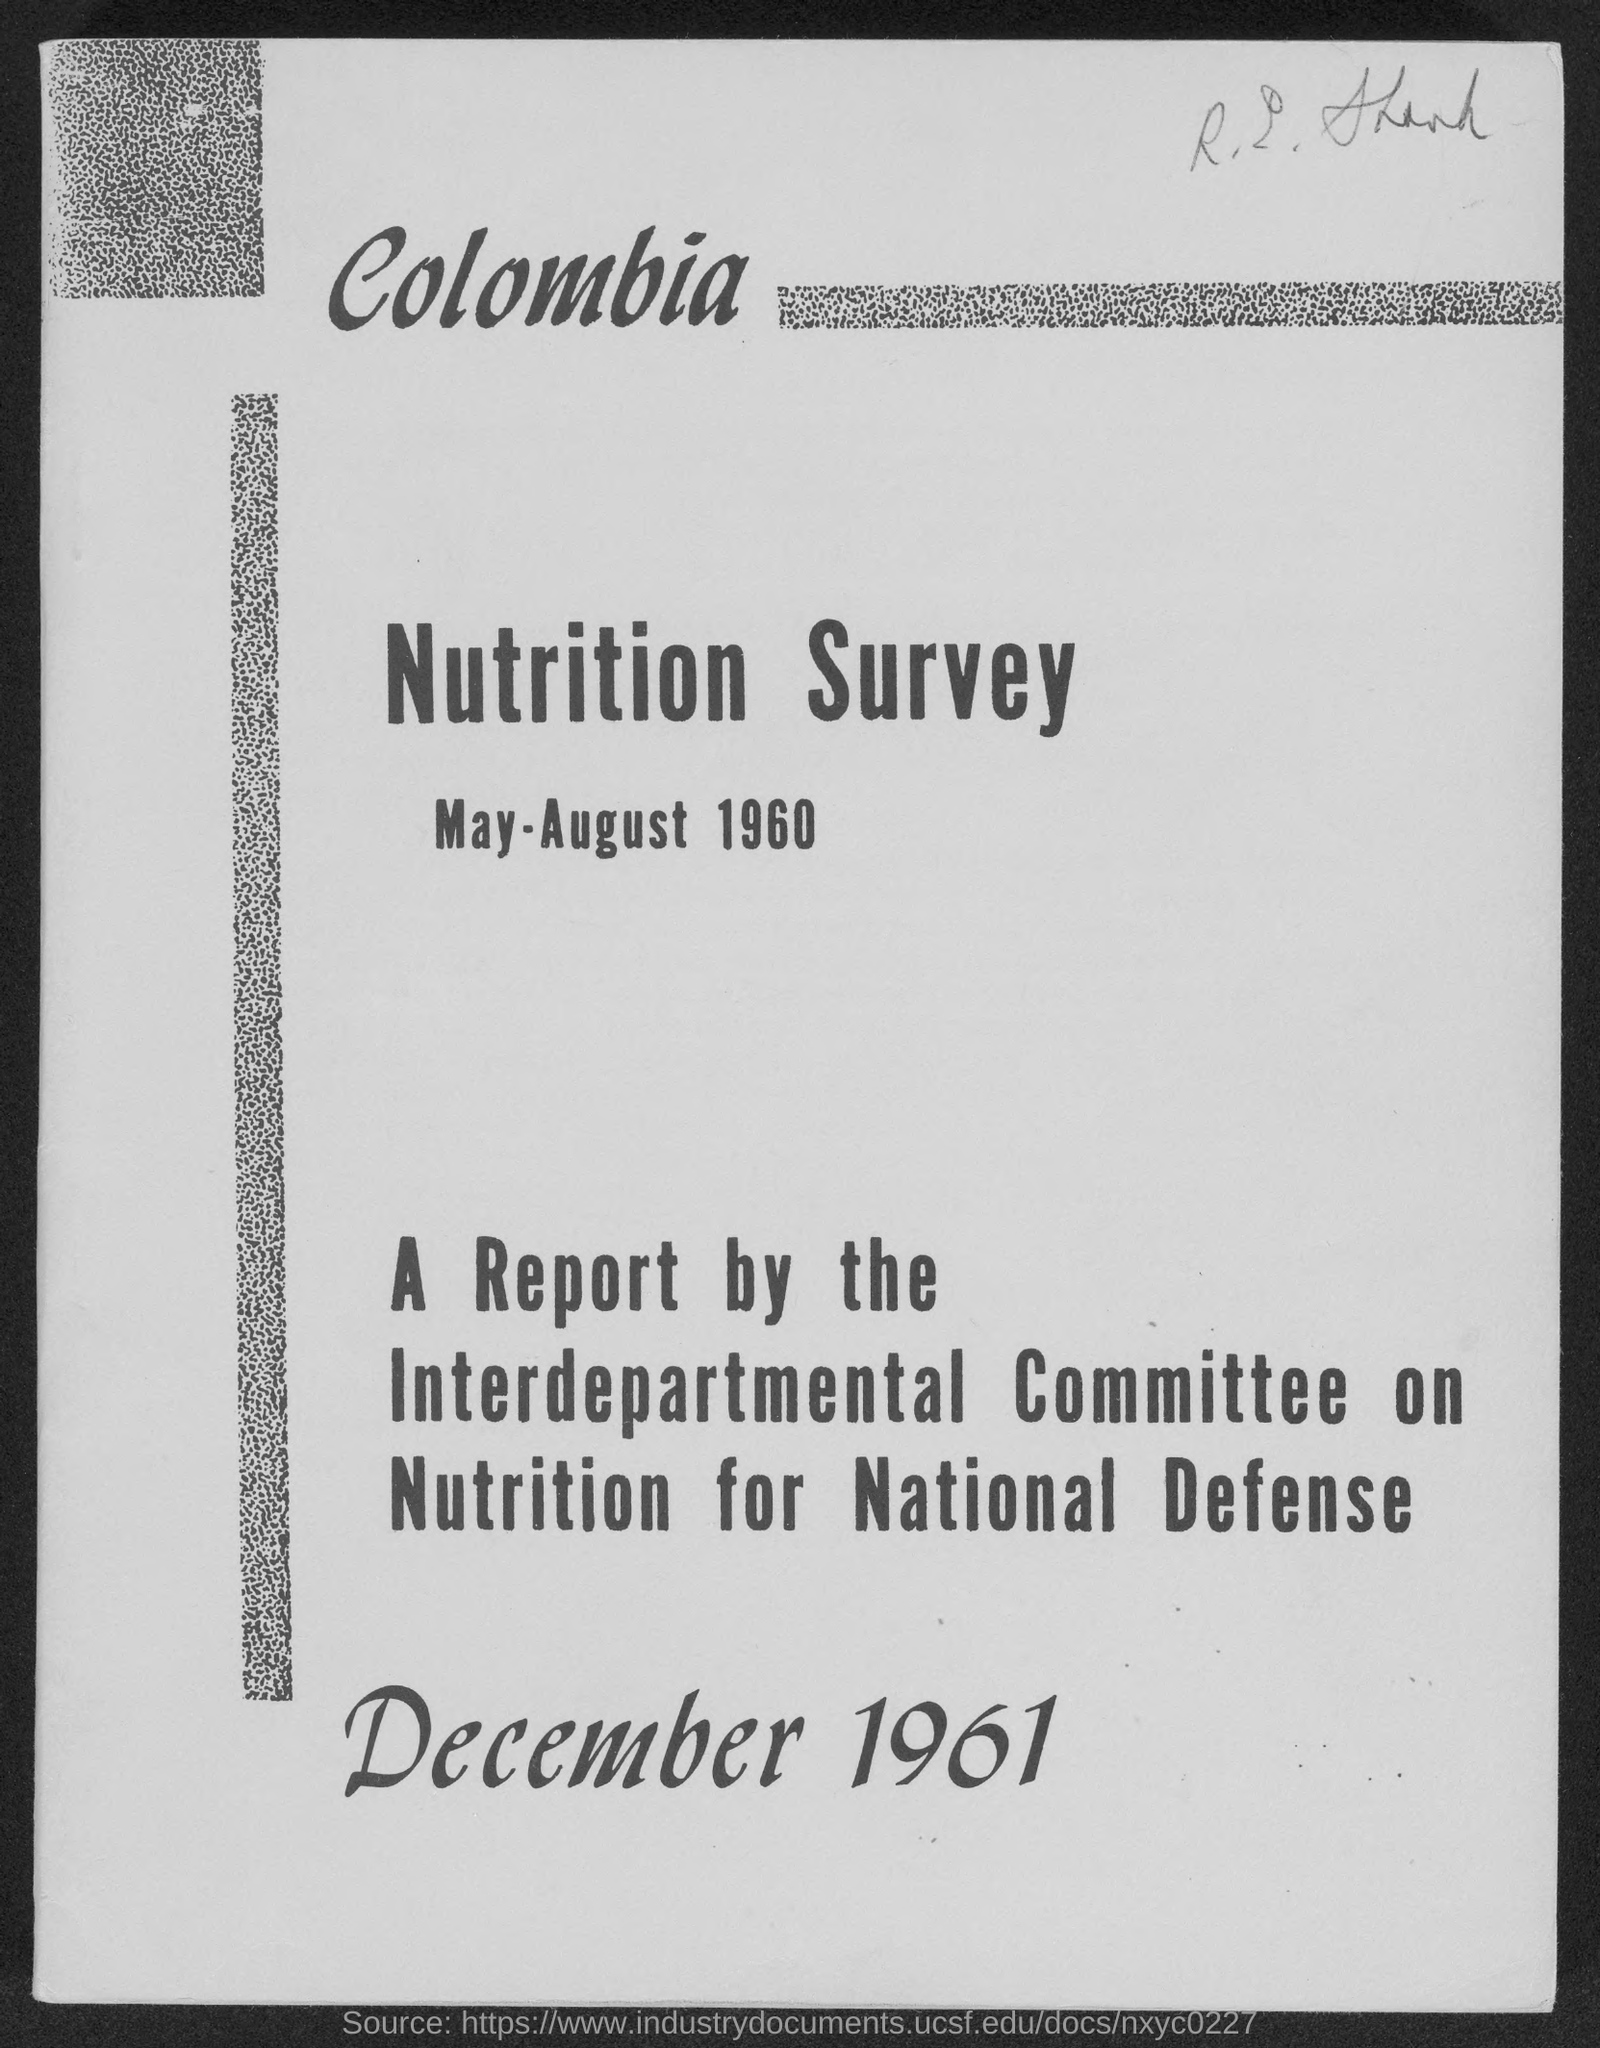When was the nutrition survey?
Ensure brevity in your answer.  May-August 1960. What is the date of the report?
Provide a short and direct response. December 1961. 